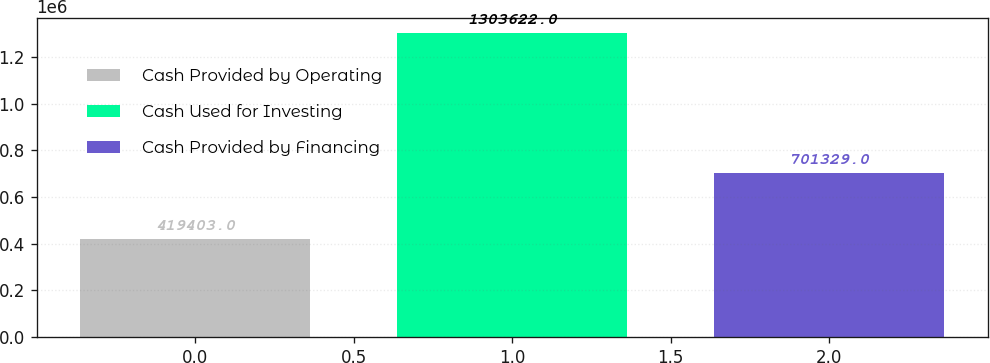Convert chart to OTSL. <chart><loc_0><loc_0><loc_500><loc_500><bar_chart><fcel>Cash Provided by Operating<fcel>Cash Used for Investing<fcel>Cash Provided by Financing<nl><fcel>419403<fcel>1.30362e+06<fcel>701329<nl></chart> 